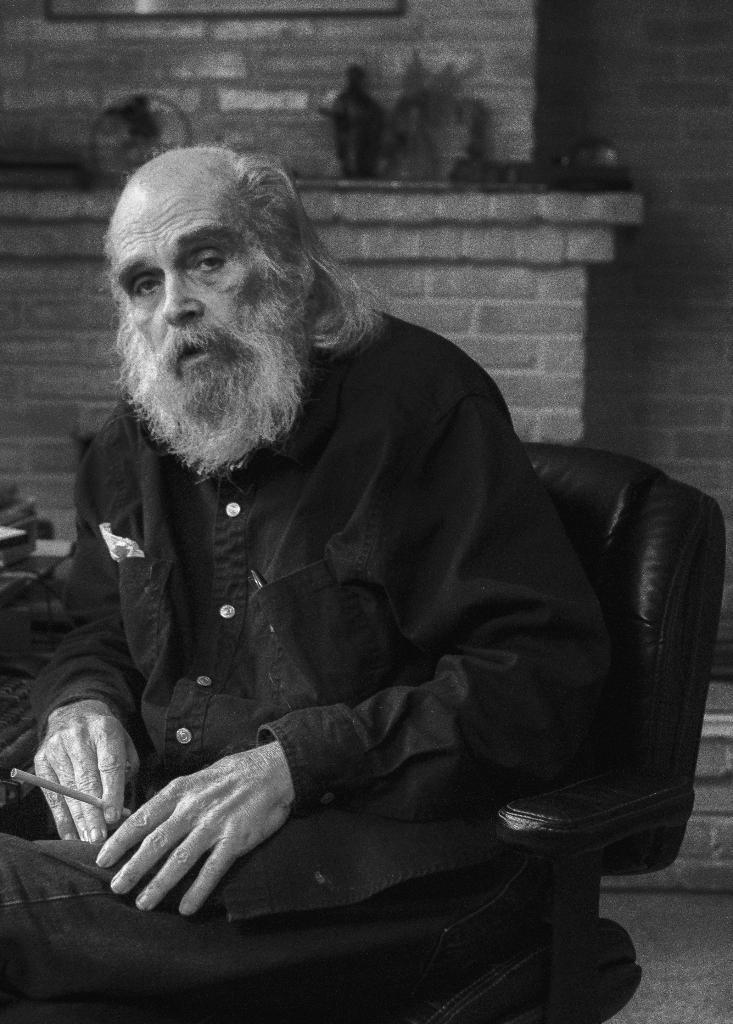In one or two sentences, can you explain what this image depicts? As we can see in the image there is a wall and a man sitting on chair. 